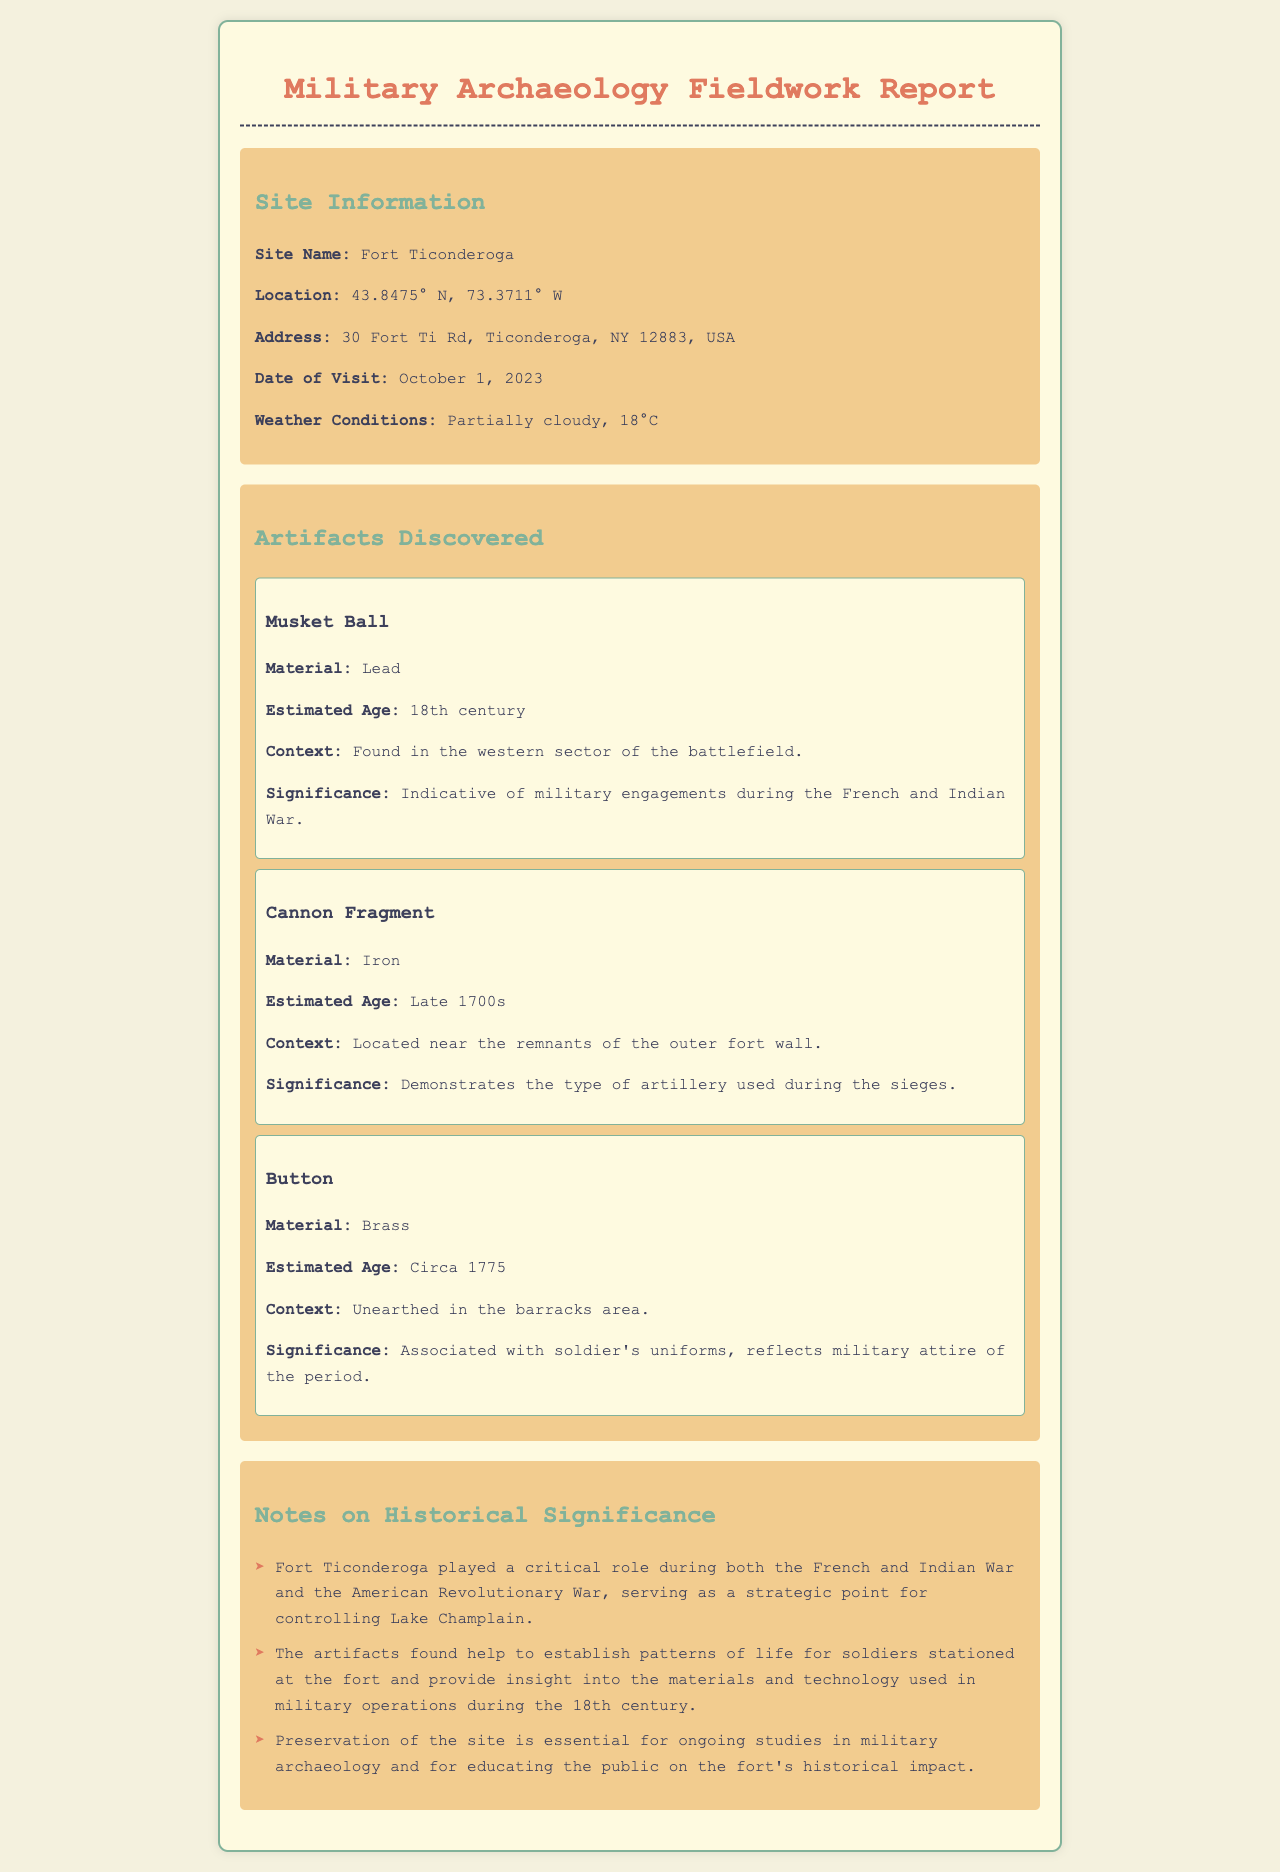What is the site name? The site name is explicitly stated under "Site Information" in the document.
Answer: Fort Ticonderoga What are the GPS coordinates of the site? The GPS coordinates are provided in the site information section of the report.
Answer: 43.8475° N, 73.3711° W What artifact was found in the barracks area? The artifact's context allows us to identify which was discovered in the barracks area.
Answer: Button What material is the cannon fragment made of? The document specifically mentions the material of the cannon fragment when describing it.
Answer: Iron What date was the field visit conducted? The document outlines the date prominently in the site information section.
Answer: October 1, 2023 Which two conflicts is Fort Ticonderoga known for? This information is synthesized from the notes on historical significance provided in the document.
Answer: French and Indian War, American Revolutionary War What does the musket ball signify? The significance of the musket ball is noted in its description in the artifacts section.
Answer: Military engagements during the French and Indian War What is the significance of preserving the site? The notes section elaborates on the importance of site preservation for military archaeology and education.
Answer: Essential for ongoing studies and education 